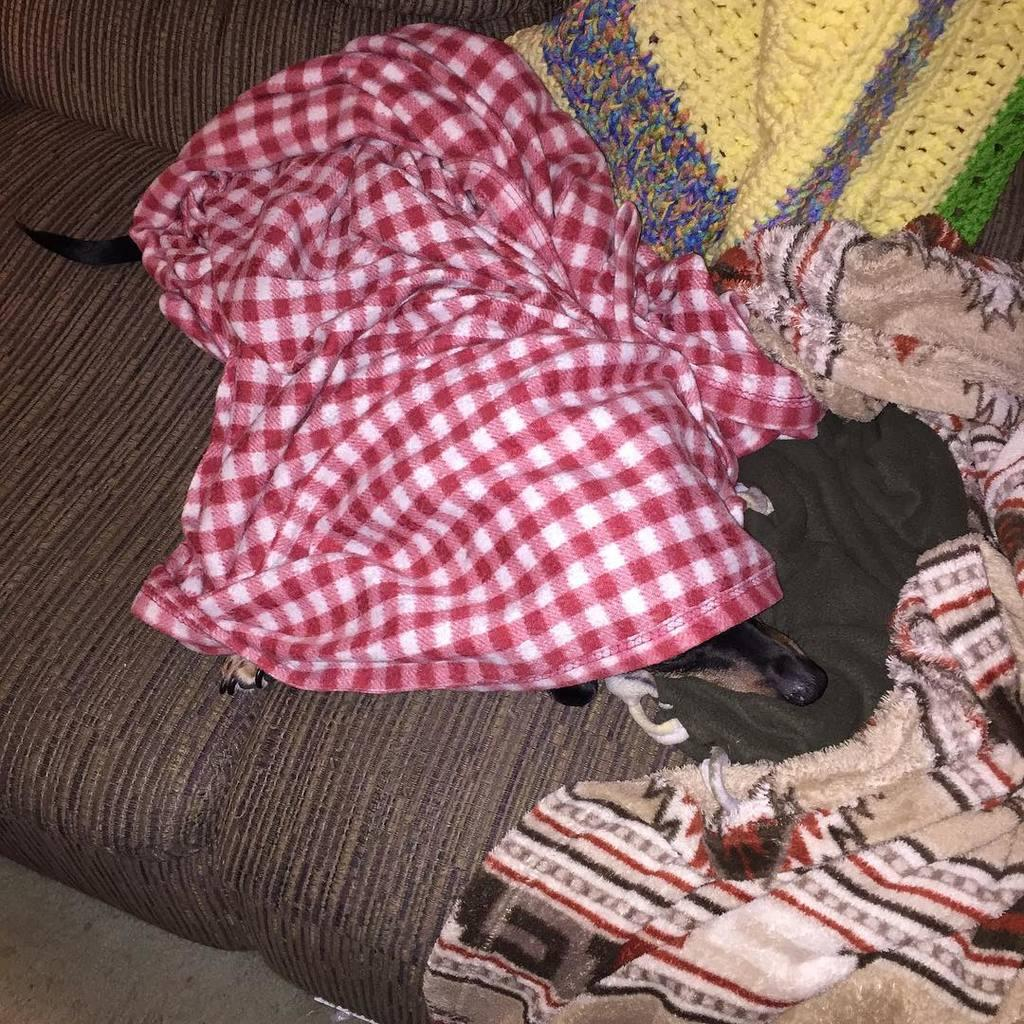What type of fabric is visible in the image? There are bed sheets in the image. What animal can be seen in the image? There is a dog in the image. Where is the dog located in the image? The dog is sleeping on a sofa. What is covering the dog in the image? The dog is under the bed sheets. What is the mass of the event happening in the image? There is no event present in the image, and therefore no mass can be associated with it. How does the dog stretch in the image? The dog is sleeping in the image and not stretching. 